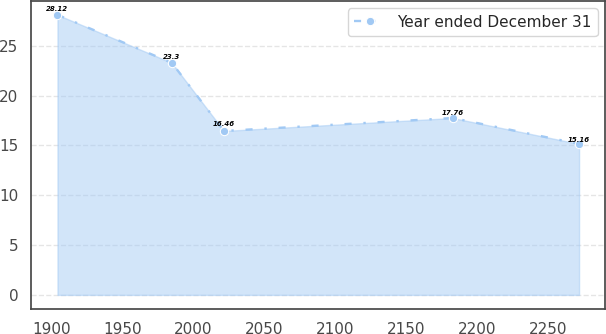Convert chart to OTSL. <chart><loc_0><loc_0><loc_500><loc_500><line_chart><ecel><fcel>Year ended December 31<nl><fcel>1904.35<fcel>28.12<nl><fcel>1984.94<fcel>23.3<nl><fcel>2021.71<fcel>16.46<nl><fcel>2182.97<fcel>17.76<nl><fcel>2272.09<fcel>15.16<nl></chart> 